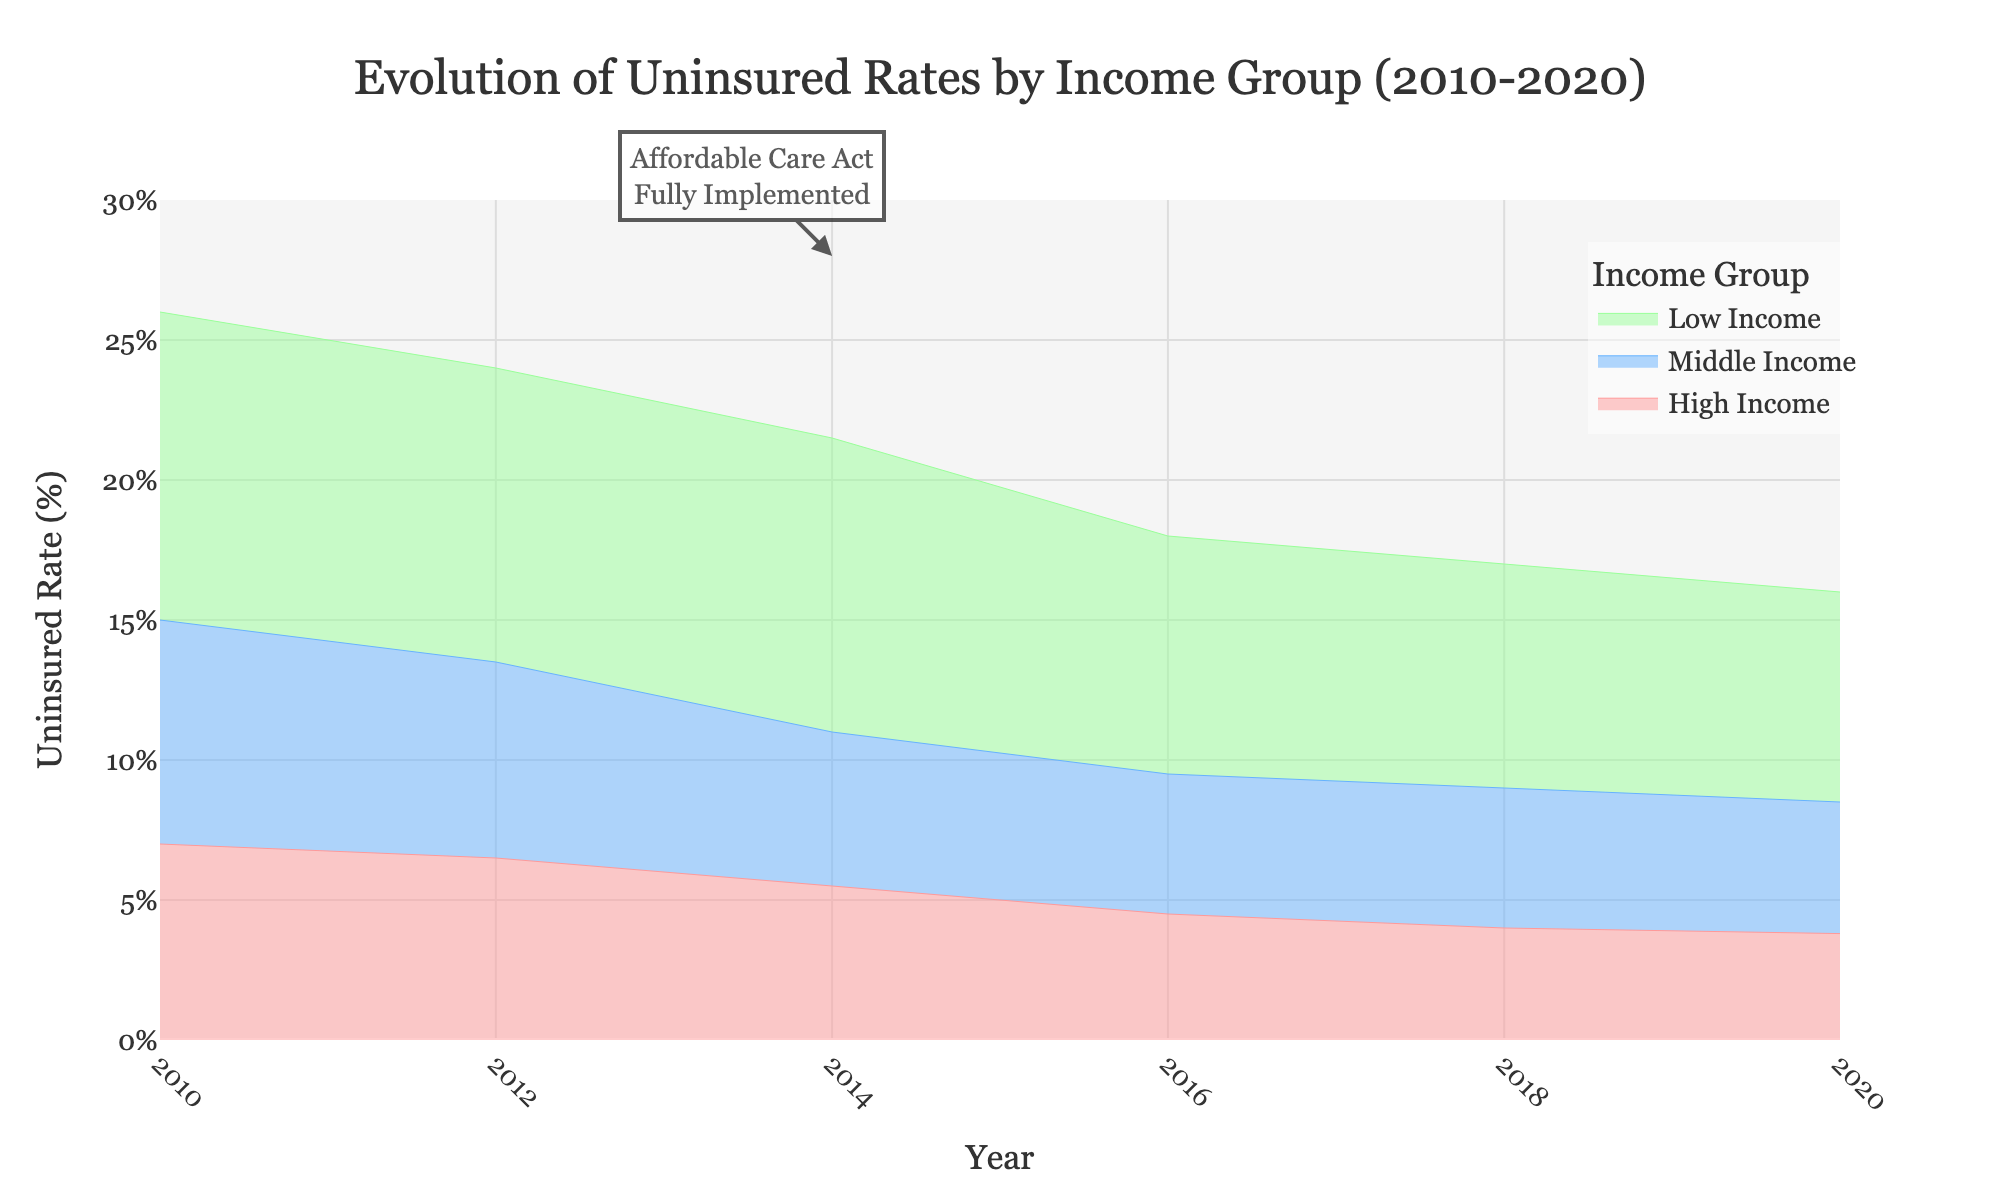How many income groups are shown in the chart? The chart depicts segments filled with different colors, each representing an income group, showing three distinct layers, which indicates there are three income groups.
Answer: 3 What does the annotation in the chart indicate? The annotation is a text box with an arrow pointing to the year 2014, which notes that the Affordable Care Act was fully implemented in that year.
Answer: Affordable Care Act Fully Implemented What is the trend in the uninsured rate for the low-income group from 2010 to 2020? Observe the solid line representing the low-income group and follow its path from 2010 to 2020. The line descends steadily from 26% in 2010 to 16% in 2020.
Answer: Decreasing Which income group has the lowest uninsured rate in 2020? Look at the end of the chart for 2020 and identify which line is the lowest. The high-income group falls at the bottom with 3.8%.
Answer: High-income group How much did the uninsured rate for middle-income group decrease from 2010 to 2016? Check the middle-income group's line; it starts from 15% in 2010 and ends at 9.5% in 2016. The decline is 15% - 9.5% = 5.5%.
Answer: 5.5% Which income group experienced the largest relative drop in uninsured rate between 2010 and 2020? Calculate the percentage decrease for each group:
- Low-income: (26% - 16%) / 26% ≈ 38.5%
- Middle-income: (15% - 8.5%) / 15% ≈ 43.3%
- High-income: (7% - 3.8%) / 7% ≈ 45.7%
The high-income group has the largest relative drop.
Answer: High-income group How do the uninsured rates of the middle-income group compare to the high-income group over the years? Each year visualize the distance between the solid lines for middle and high-income groups, noting that middle-income group uninsured rates are consistently higher but the gap narrows over time.
Answer: Higher consistently, but gap narrows By how much did the uninsured rate for the low-income group decline from 2014 to 2018? Follow the low-income group's line from 2014 to 2018, seeing a decline from 21.5% to 17%, so the decrease is 21.5% - 17% = 4.5%.
Answer: 4.5% What is the average uninsured rate for the high-income group across all years displayed? Add up all the uninsured rates of the high-income group (7.0 + 6.5 + 5.5 + 4.5 + 4.0 + 3.8) = 31.3, and divide by the number of data points (6), so 31.3/6 ≈ 5.22%.
Answer: 5.22% What does the trend of uninsured rates indicate about the impact of the Affordable Care Act? Observe the overall descending trends for all income groups after 2014, suggesting the Affordable Care Act effectively reduced uninsured rates across all groups.
Answer: Positive impact 